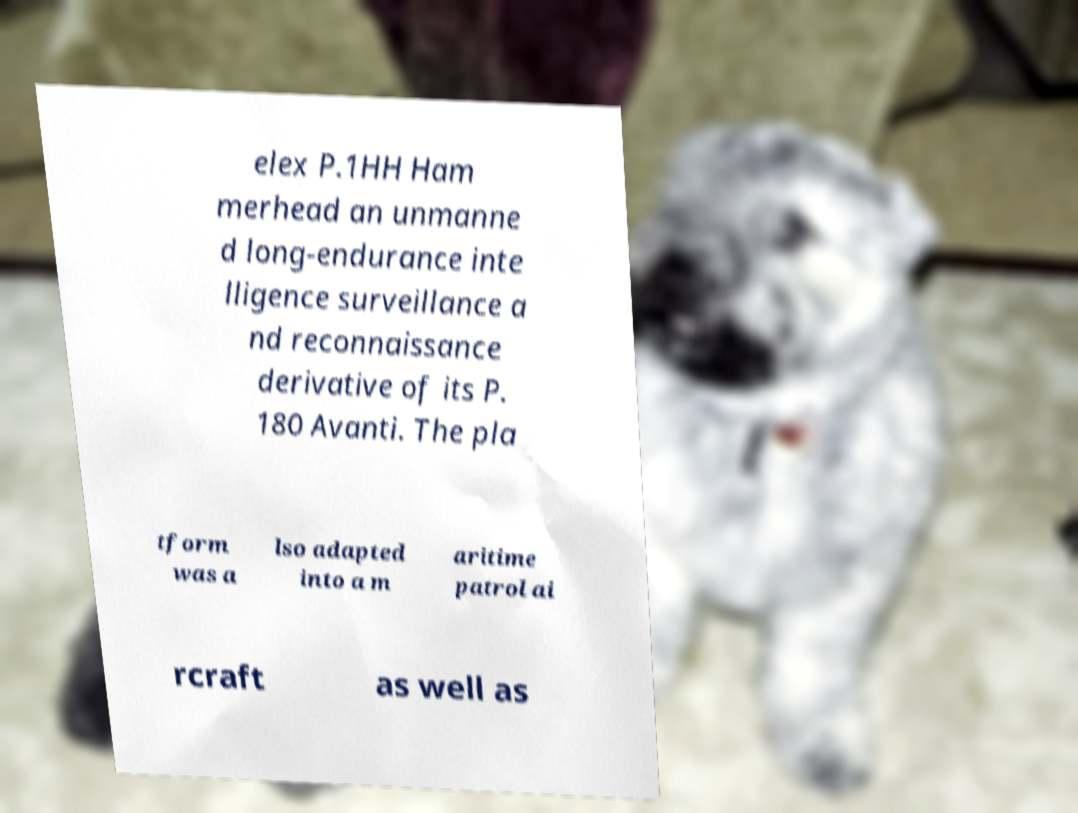Can you read and provide the text displayed in the image?This photo seems to have some interesting text. Can you extract and type it out for me? elex P.1HH Ham merhead an unmanne d long-endurance inte lligence surveillance a nd reconnaissance derivative of its P. 180 Avanti. The pla tform was a lso adapted into a m aritime patrol ai rcraft as well as 